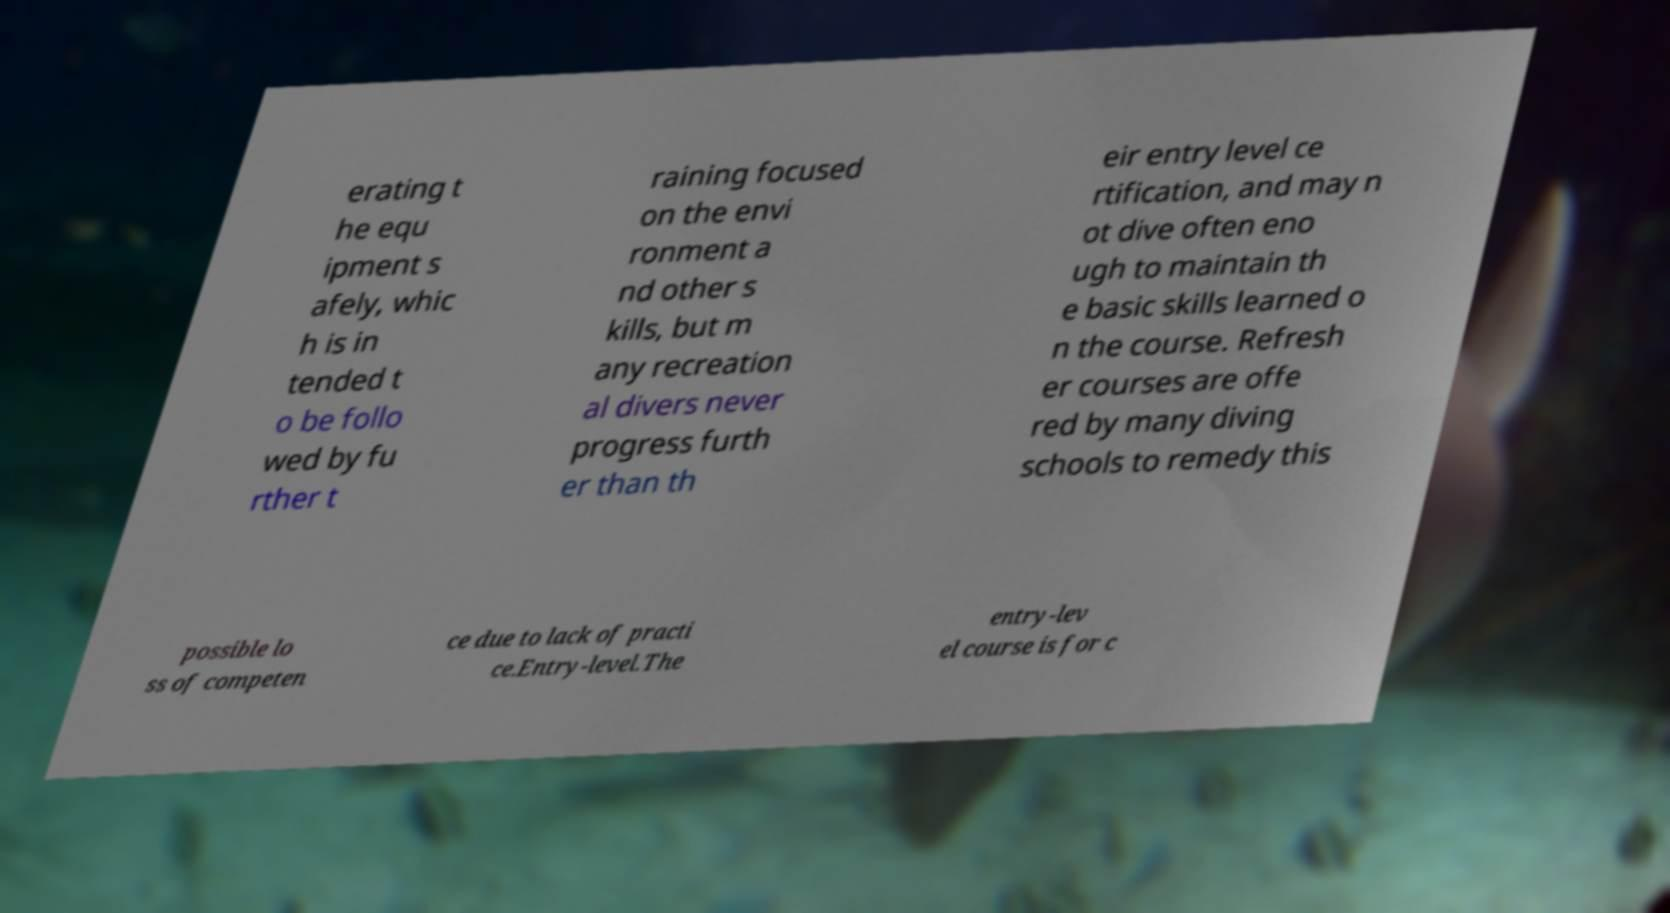Please identify and transcribe the text found in this image. erating t he equ ipment s afely, whic h is in tended t o be follo wed by fu rther t raining focused on the envi ronment a nd other s kills, but m any recreation al divers never progress furth er than th eir entry level ce rtification, and may n ot dive often eno ugh to maintain th e basic skills learned o n the course. Refresh er courses are offe red by many diving schools to remedy this possible lo ss of competen ce due to lack of practi ce.Entry-level.The entry-lev el course is for c 